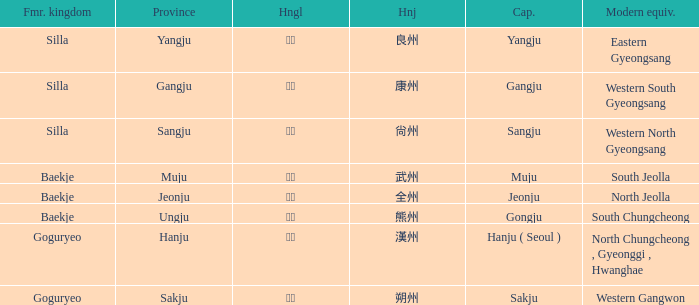What are the modern equivalents for the province of "hanju"? North Chungcheong , Gyeonggi , Hwanghae. 